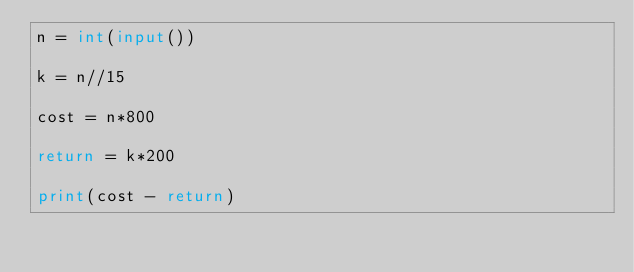<code> <loc_0><loc_0><loc_500><loc_500><_Python_>n = int(input())

k = n//15

cost = n*800

return = k*200

print(cost - return)</code> 